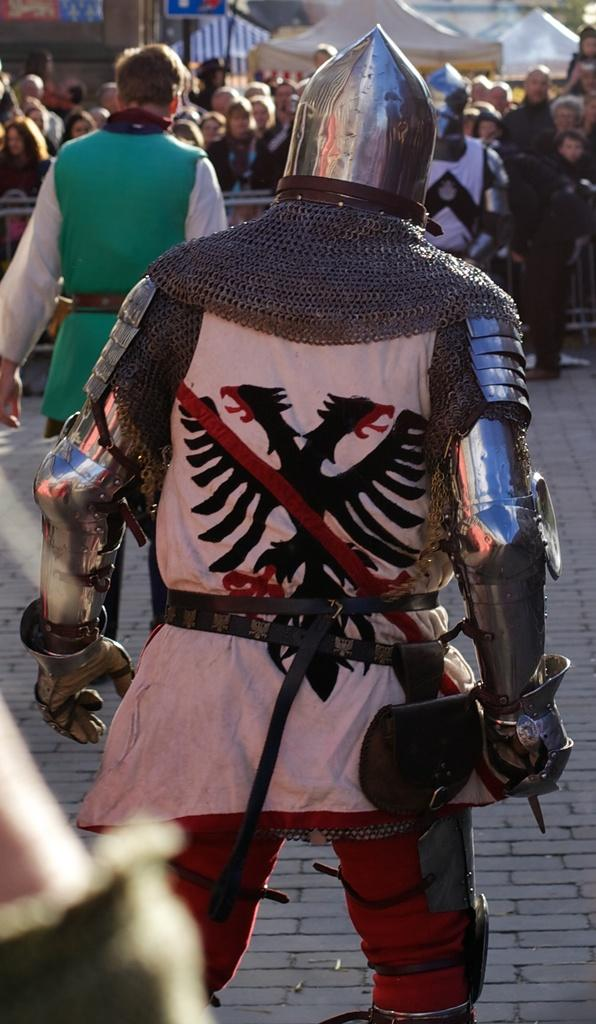What is happening in the center of the image? There are persons on the ground in the center of the image. Can you describe the background of the image? There are persons visible in the background, along with tents and at least one building. What type of structures can be seen in the background? There are tents in the background of the image. How many buildings are visible in the background? There is at least one building visible in the background. What type of rhythm can be heard coming from the camera in the image? There is no camera present in the image, and therefore no rhythm can be heard. Can you tell me how many toothbrushes are visible in the image? There are no toothbrushes present in the image. 